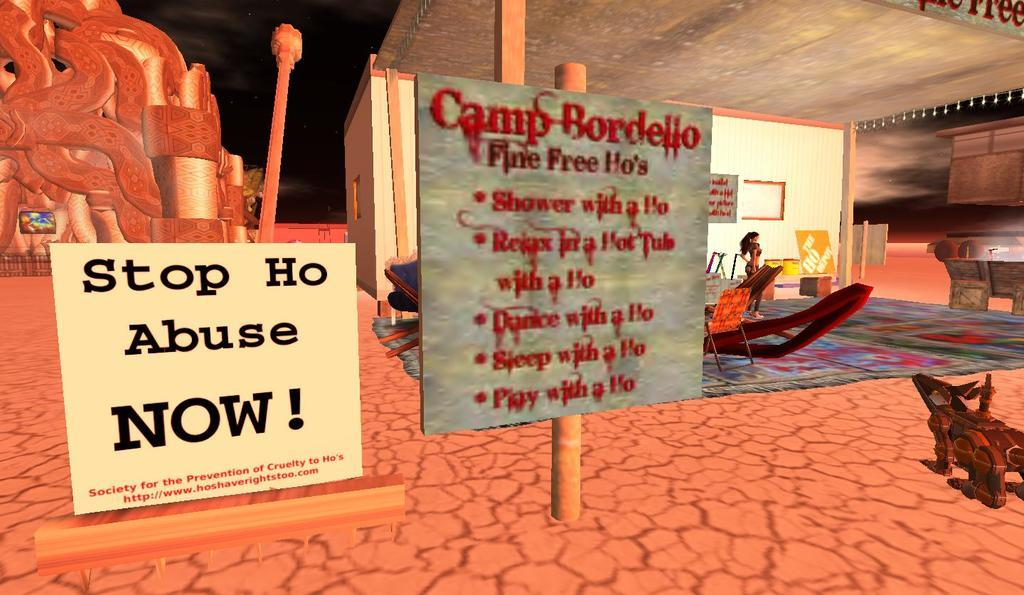<image>
Render a clear and concise summary of the photo. A sign erected in a virtual world setting for a place called Camp Bordello. 